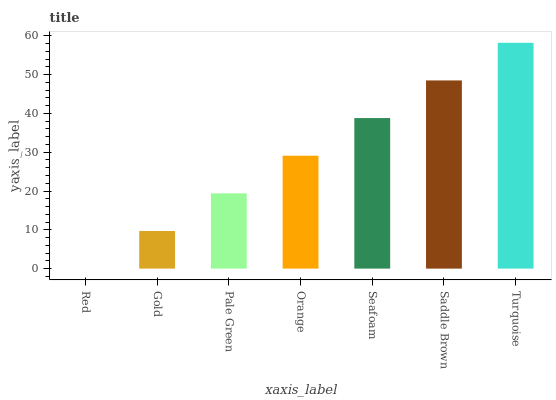Is Gold the minimum?
Answer yes or no. No. Is Gold the maximum?
Answer yes or no. No. Is Gold greater than Red?
Answer yes or no. Yes. Is Red less than Gold?
Answer yes or no. Yes. Is Red greater than Gold?
Answer yes or no. No. Is Gold less than Red?
Answer yes or no. No. Is Orange the high median?
Answer yes or no. Yes. Is Orange the low median?
Answer yes or no. Yes. Is Red the high median?
Answer yes or no. No. Is Gold the low median?
Answer yes or no. No. 